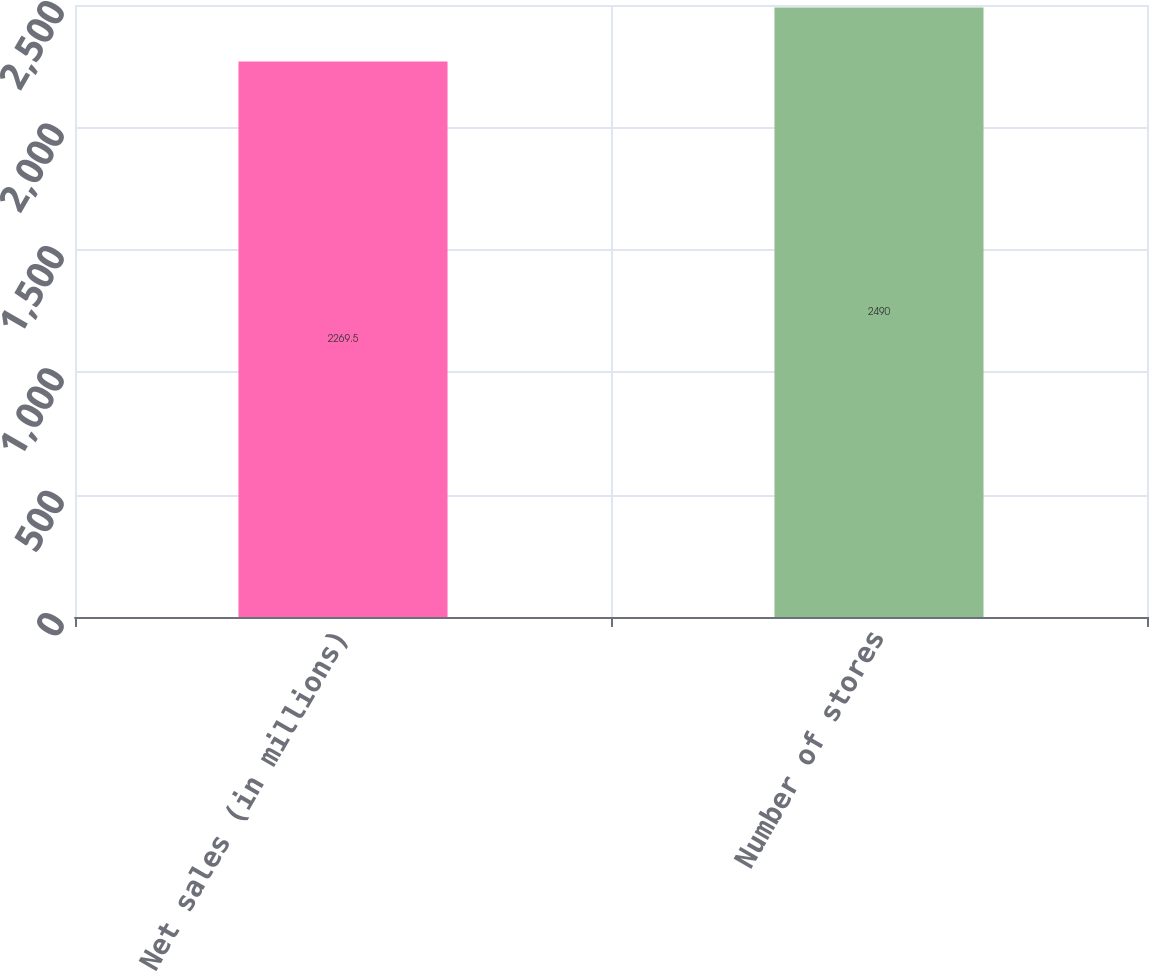Convert chart to OTSL. <chart><loc_0><loc_0><loc_500><loc_500><bar_chart><fcel>Net sales (in millions)<fcel>Number of stores<nl><fcel>2269.5<fcel>2490<nl></chart> 